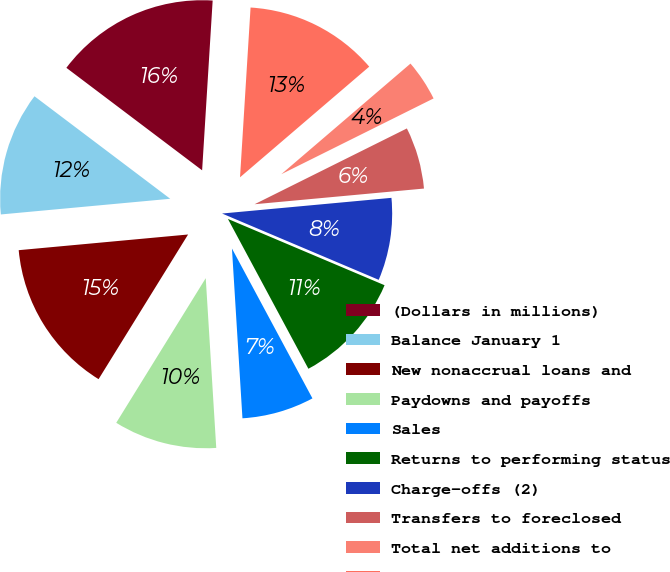Convert chart. <chart><loc_0><loc_0><loc_500><loc_500><pie_chart><fcel>(Dollars in millions)<fcel>Balance January 1<fcel>New nonaccrual loans and<fcel>Paydowns and payoffs<fcel>Sales<fcel>Returns to performing status<fcel>Charge-offs (2)<fcel>Transfers to foreclosed<fcel>Total net additions to<fcel>Total nonperforming loans and<nl><fcel>15.69%<fcel>11.76%<fcel>14.71%<fcel>9.8%<fcel>6.86%<fcel>10.78%<fcel>7.84%<fcel>5.88%<fcel>3.92%<fcel>12.74%<nl></chart> 